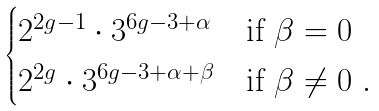<formula> <loc_0><loc_0><loc_500><loc_500>\begin{cases} 2 ^ { 2 g - 1 } \cdot 3 ^ { 6 g - 3 + \alpha } & \text {if $\beta = 0$} \\ 2 ^ { 2 g } \cdot 3 ^ { 6 g - 3 + \alpha + \beta } & \text {if $\beta \neq 0$} \ . \end{cases}</formula> 